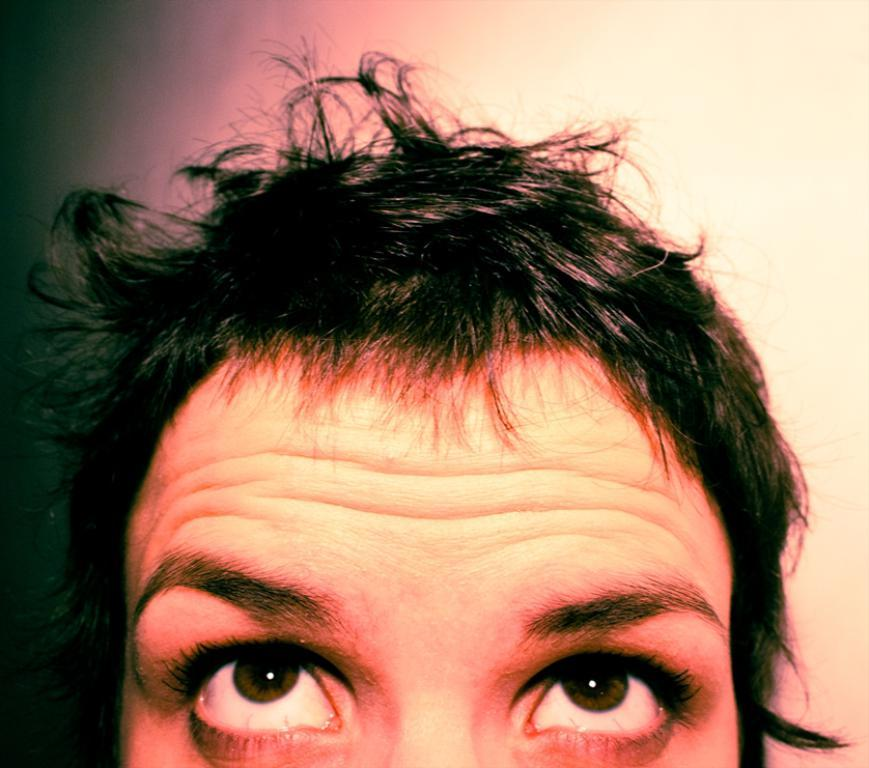Who or what is present in the image? There is a person in the image. What can be seen in the background of the image? There is a wall in the background of the image. How many fans are visible in the image? There are no fans present in the image. 